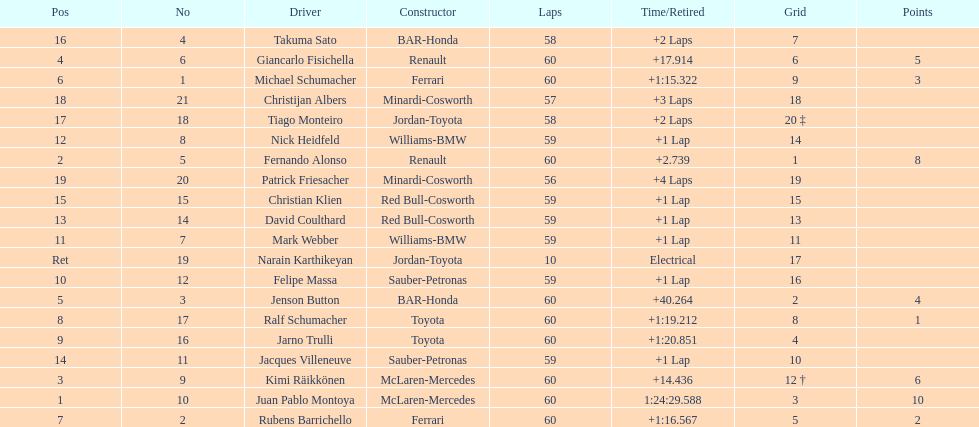How many drivers from germany? 3. 